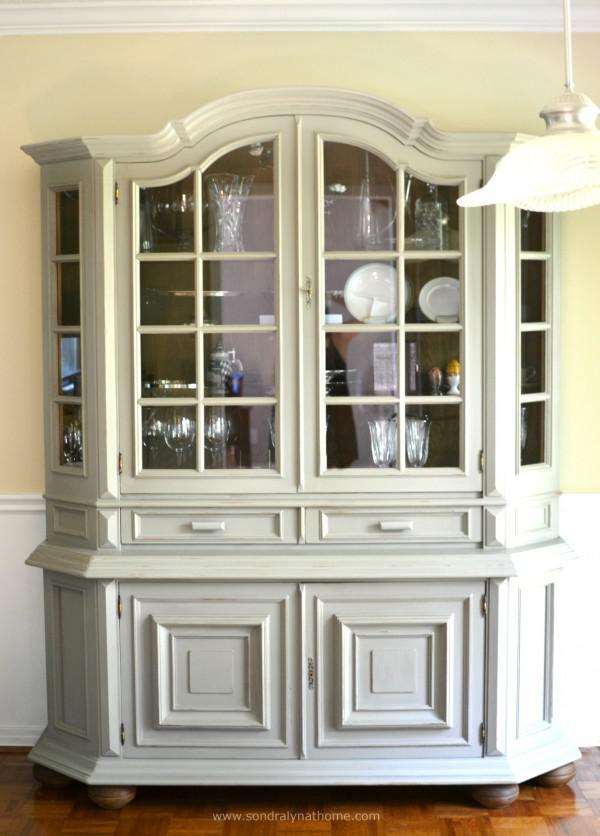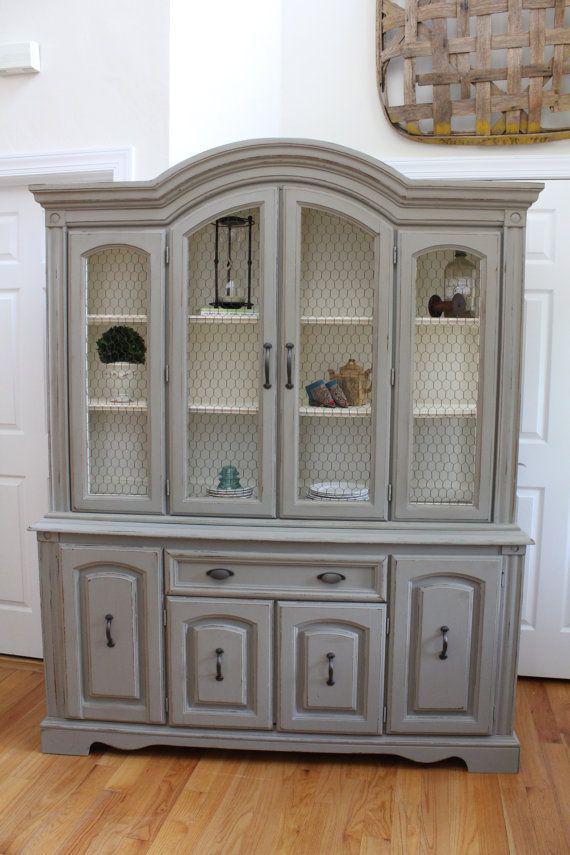The first image is the image on the left, the second image is the image on the right. For the images shown, is this caption "At least one of the cabinets has an arched top as well as some type of legs." true? Answer yes or no. Yes. 